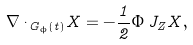<formula> <loc_0><loc_0><loc_500><loc_500>\nabla _ { \dot { \ } G _ { \phi } ( t ) } X = - \frac { 1 } { 2 } \Phi \, J _ { Z } X ,</formula> 